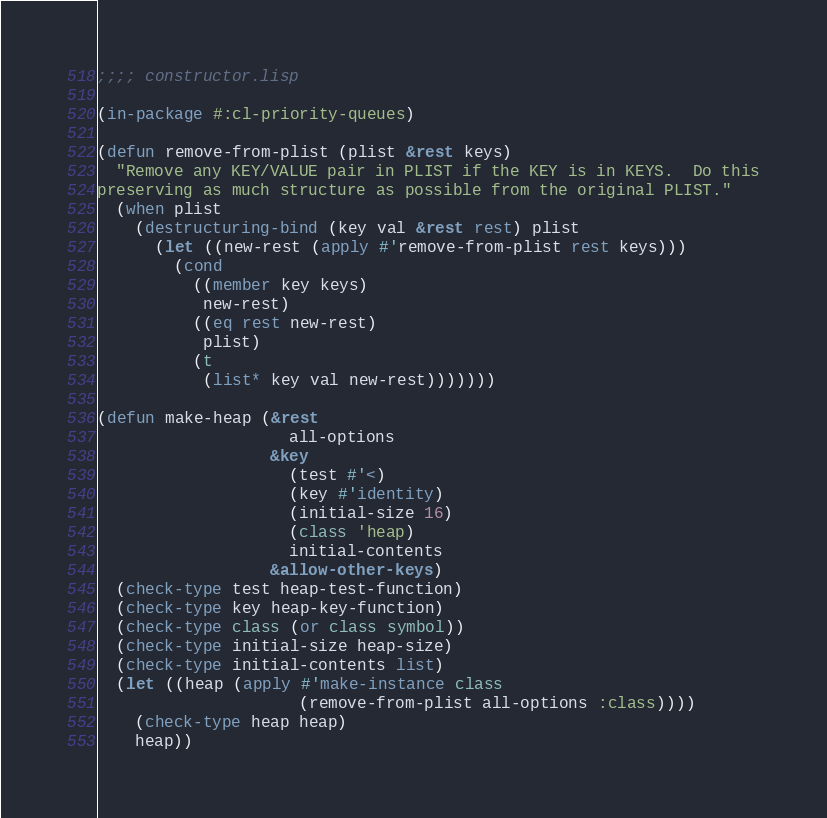Convert code to text. <code><loc_0><loc_0><loc_500><loc_500><_Lisp_>;;;; constructor.lisp

(in-package #:cl-priority-queues)

(defun remove-from-plist (plist &rest keys)
  "Remove any KEY/VALUE pair in PLIST if the KEY is in KEYS.  Do this
preserving as much structure as possible from the original PLIST."
  (when plist
    (destructuring-bind (key val &rest rest) plist
      (let ((new-rest (apply #'remove-from-plist rest keys)))
        (cond
          ((member key keys)
           new-rest)
          ((eq rest new-rest)
           plist)
          (t
           (list* key val new-rest)))))))

(defun make-heap (&rest
                    all-options
                  &key
                    (test #'<)
                    (key #'identity)
                    (initial-size 16)
                    (class 'heap)
                    initial-contents
                  &allow-other-keys)
  (check-type test heap-test-function)
  (check-type key heap-key-function)
  (check-type class (or class symbol))
  (check-type initial-size heap-size)
  (check-type initial-contents list)
  (let ((heap (apply #'make-instance class
                     (remove-from-plist all-options :class))))
    (check-type heap heap)
    heap))
</code> 